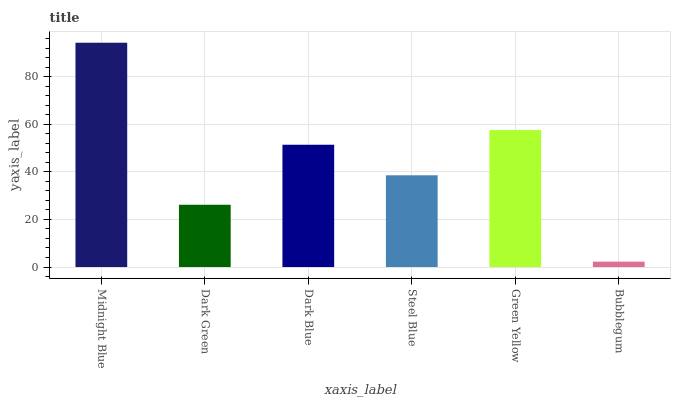Is Bubblegum the minimum?
Answer yes or no. Yes. Is Midnight Blue the maximum?
Answer yes or no. Yes. Is Dark Green the minimum?
Answer yes or no. No. Is Dark Green the maximum?
Answer yes or no. No. Is Midnight Blue greater than Dark Green?
Answer yes or no. Yes. Is Dark Green less than Midnight Blue?
Answer yes or no. Yes. Is Dark Green greater than Midnight Blue?
Answer yes or no. No. Is Midnight Blue less than Dark Green?
Answer yes or no. No. Is Dark Blue the high median?
Answer yes or no. Yes. Is Steel Blue the low median?
Answer yes or no. Yes. Is Green Yellow the high median?
Answer yes or no. No. Is Bubblegum the low median?
Answer yes or no. No. 